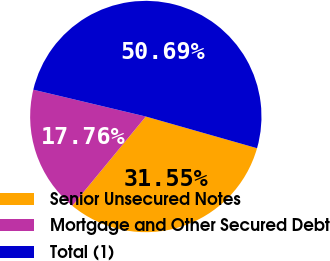<chart> <loc_0><loc_0><loc_500><loc_500><pie_chart><fcel>Senior Unsecured Notes<fcel>Mortgage and Other Secured Debt<fcel>Total (1)<nl><fcel>31.55%<fcel>17.76%<fcel>50.69%<nl></chart> 